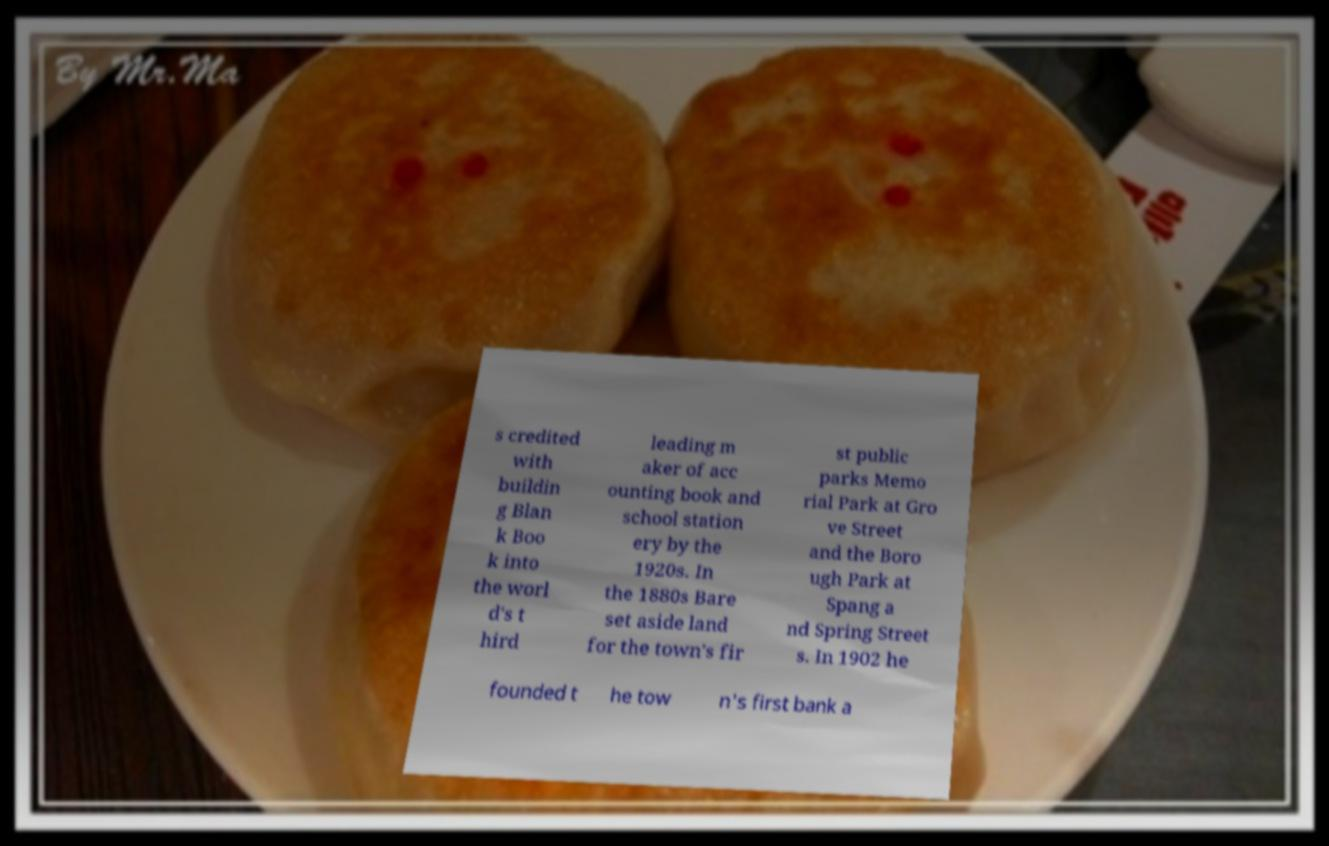Could you extract and type out the text from this image? s credited with buildin g Blan k Boo k into the worl d's t hird leading m aker of acc ounting book and school station ery by the 1920s. In the 1880s Bare set aside land for the town's fir st public parks Memo rial Park at Gro ve Street and the Boro ugh Park at Spang a nd Spring Street s. In 1902 he founded t he tow n's first bank a 